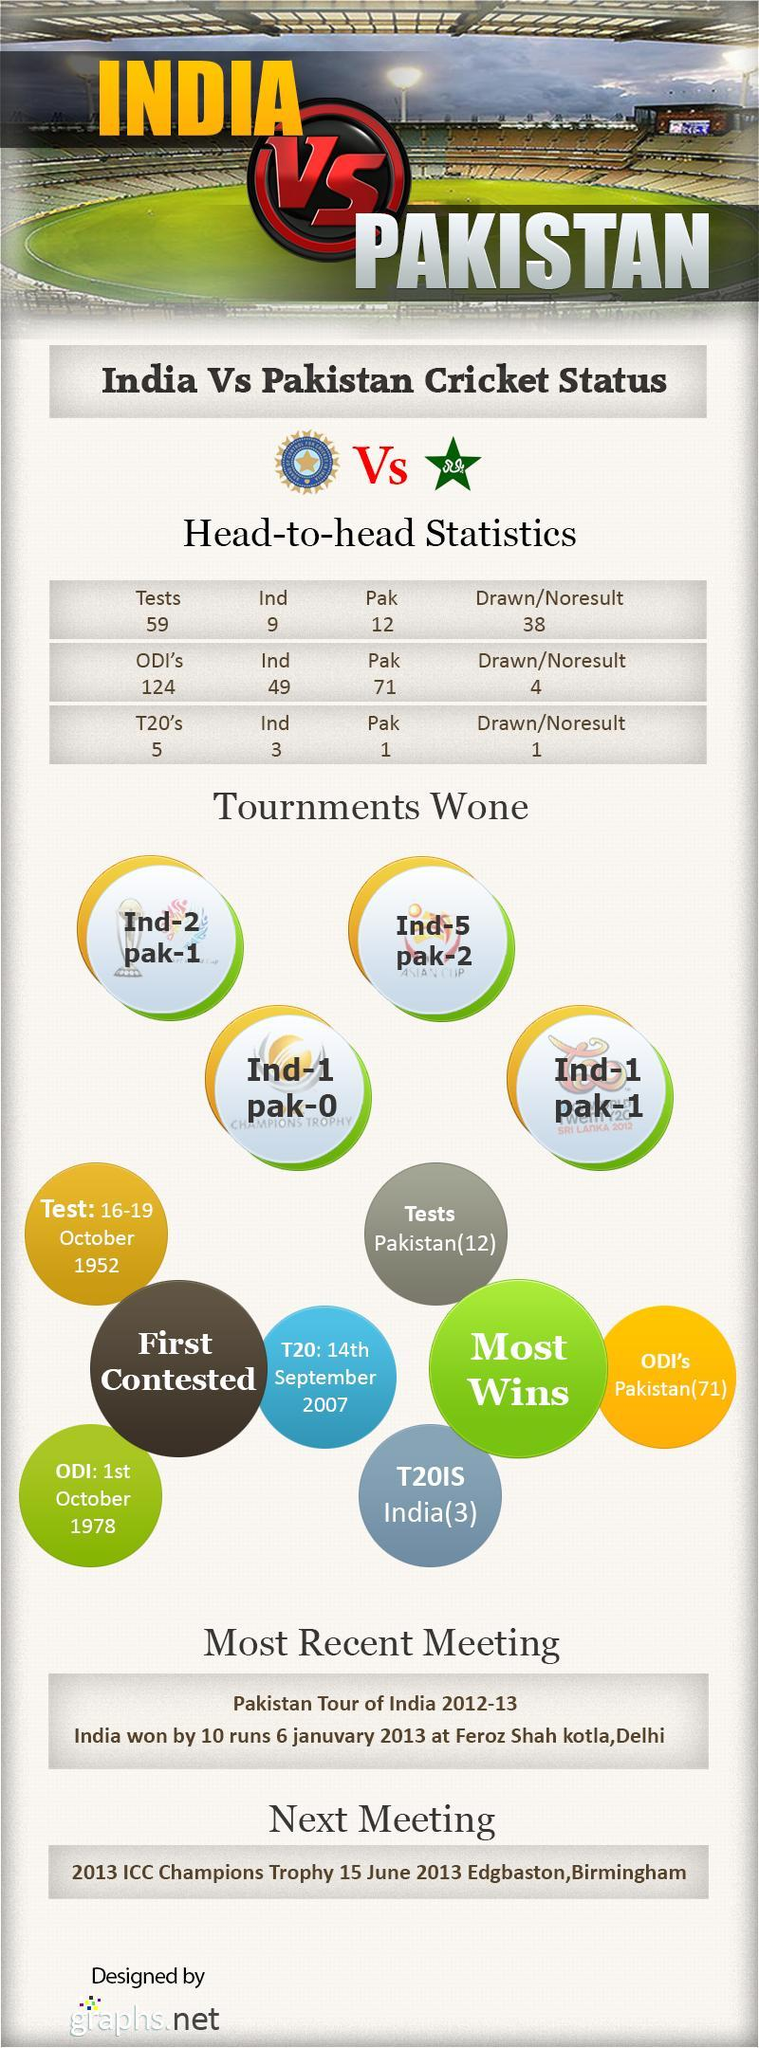When was the last cricket match between India and Pakistan?.
Answer the question with a short phrase. 6 januvary 2013 Which are the different formats of Cricket? Tests, ODI's, T20's When did the first twenty-twenty match happen between India and Pakistan? 14th September 2007 How many formats are there for Cricket? 3 India won how many Asian Cup? 5 Pakistan won how many World Cup? 1 How many matches were won by India against Pakistan in ICC World Twenty-Twenty 2012? 1 